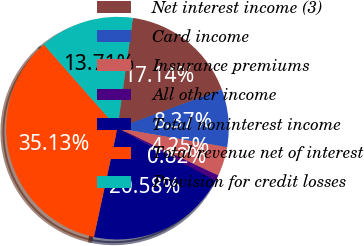Convert chart. <chart><loc_0><loc_0><loc_500><loc_500><pie_chart><fcel>Net interest income (3)<fcel>Card income<fcel>Insurance premiums<fcel>All other income<fcel>Total noninterest income<fcel>Total revenue net of interest<fcel>Provision for credit losses<nl><fcel>17.14%<fcel>8.37%<fcel>4.25%<fcel>0.82%<fcel>20.58%<fcel>35.13%<fcel>13.71%<nl></chart> 